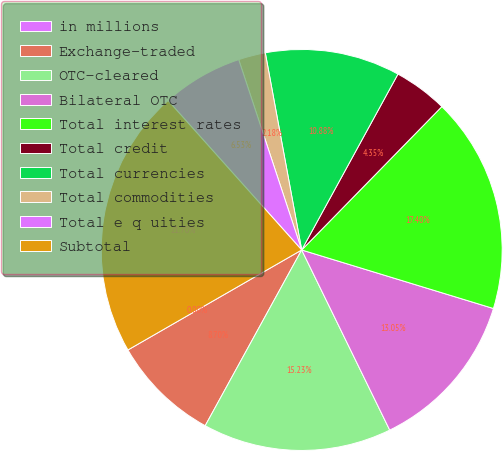Convert chart to OTSL. <chart><loc_0><loc_0><loc_500><loc_500><pie_chart><fcel>in millions<fcel>Exchange-traded<fcel>OTC-cleared<fcel>Bilateral OTC<fcel>Total interest rates<fcel>Total credit<fcel>Total currencies<fcel>Total commodities<fcel>Total e q uities<fcel>Subtotal<nl><fcel>0.0%<fcel>8.7%<fcel>15.23%<fcel>13.05%<fcel>17.4%<fcel>4.35%<fcel>10.88%<fcel>2.18%<fcel>6.53%<fcel>21.7%<nl></chart> 